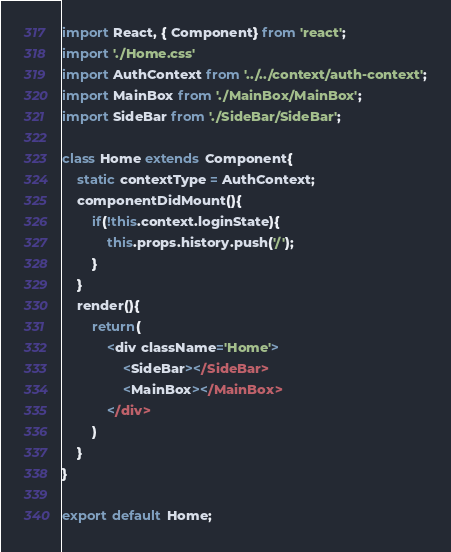Convert code to text. <code><loc_0><loc_0><loc_500><loc_500><_JavaScript_>import React, { Component} from 'react';
import './Home.css'
import AuthContext from '../../context/auth-context';
import MainBox from './MainBox/MainBox';
import SideBar from './SideBar/SideBar';

class Home extends Component{
    static contextType = AuthContext;
    componentDidMount(){
        if(!this.context.loginState){
            this.props.history.push('/');
        }
    }
    render(){
        return(
            <div className='Home'>
                <SideBar></SideBar>
                <MainBox></MainBox>
            </div>
        )
    }
}

export default Home;</code> 